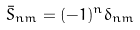<formula> <loc_0><loc_0><loc_500><loc_500>\bar { S } _ { n m } = ( - 1 ) ^ { n } \delta _ { n m }</formula> 